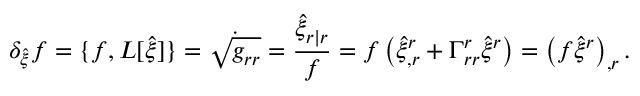<formula> <loc_0><loc_0><loc_500><loc_500>\delta _ { \hat { \xi } } f = \{ f , L [ \hat { \xi } ] \} = \dot { \sqrt { g _ { r r } } } = \frac { \hat { \xi } _ { r | r } } { f } = f \left ( \hat { \xi } _ { , r } ^ { r } + \Gamma _ { r r } ^ { r } \hat { \xi } ^ { r } \right ) = \left ( f \hat { \xi } ^ { r } \right ) _ { , r } .</formula> 